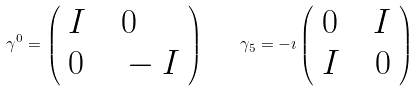Convert formula to latex. <formula><loc_0><loc_0><loc_500><loc_500>\gamma ^ { 0 } = \left ( \begin{array} { l l } I \quad 0 \\ 0 \quad - I \end{array} \right ) \quad \gamma _ { 5 } = - \imath \left ( \begin{array} { l l } 0 \quad I \\ I \quad 0 \end{array} \right )</formula> 